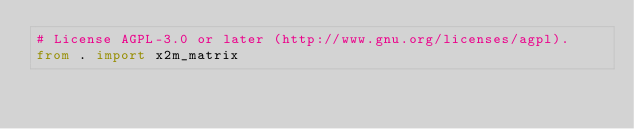<code> <loc_0><loc_0><loc_500><loc_500><_Python_># License AGPL-3.0 or later (http://www.gnu.org/licenses/agpl).
from . import x2m_matrix
</code> 